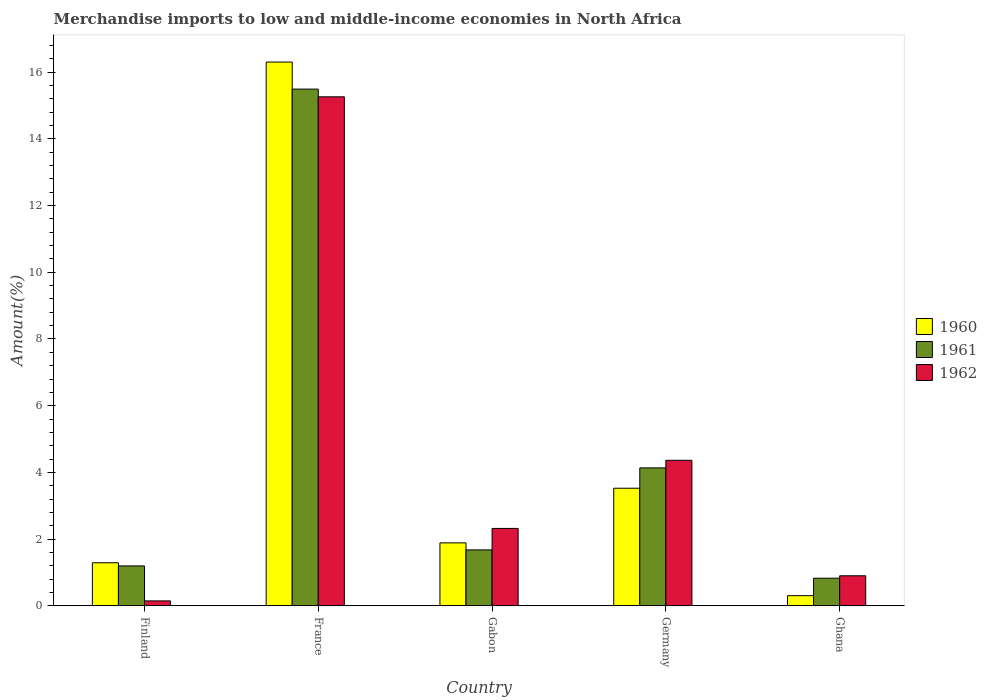How many groups of bars are there?
Give a very brief answer. 5. Are the number of bars on each tick of the X-axis equal?
Ensure brevity in your answer.  Yes. How many bars are there on the 1st tick from the left?
Ensure brevity in your answer.  3. How many bars are there on the 5th tick from the right?
Provide a short and direct response. 3. What is the label of the 3rd group of bars from the left?
Offer a terse response. Gabon. In how many cases, is the number of bars for a given country not equal to the number of legend labels?
Make the answer very short. 0. What is the percentage of amount earned from merchandise imports in 1962 in Ghana?
Your answer should be compact. 0.9. Across all countries, what is the maximum percentage of amount earned from merchandise imports in 1961?
Your answer should be very brief. 15.49. Across all countries, what is the minimum percentage of amount earned from merchandise imports in 1961?
Provide a succinct answer. 0.83. In which country was the percentage of amount earned from merchandise imports in 1962 maximum?
Ensure brevity in your answer.  France. In which country was the percentage of amount earned from merchandise imports in 1962 minimum?
Your response must be concise. Finland. What is the total percentage of amount earned from merchandise imports in 1961 in the graph?
Keep it short and to the point. 23.33. What is the difference between the percentage of amount earned from merchandise imports in 1961 in Germany and that in Ghana?
Your answer should be compact. 3.31. What is the difference between the percentage of amount earned from merchandise imports in 1962 in Ghana and the percentage of amount earned from merchandise imports in 1960 in Finland?
Offer a terse response. -0.39. What is the average percentage of amount earned from merchandise imports in 1960 per country?
Provide a short and direct response. 4.66. What is the difference between the percentage of amount earned from merchandise imports of/in 1961 and percentage of amount earned from merchandise imports of/in 1960 in France?
Provide a succinct answer. -0.81. What is the ratio of the percentage of amount earned from merchandise imports in 1961 in Gabon to that in Ghana?
Keep it short and to the point. 2.03. Is the percentage of amount earned from merchandise imports in 1962 in Finland less than that in France?
Offer a terse response. Yes. Is the difference between the percentage of amount earned from merchandise imports in 1961 in France and Gabon greater than the difference between the percentage of amount earned from merchandise imports in 1960 in France and Gabon?
Ensure brevity in your answer.  No. What is the difference between the highest and the second highest percentage of amount earned from merchandise imports in 1961?
Give a very brief answer. -2.46. What is the difference between the highest and the lowest percentage of amount earned from merchandise imports in 1960?
Keep it short and to the point. 16. Is it the case that in every country, the sum of the percentage of amount earned from merchandise imports in 1961 and percentage of amount earned from merchandise imports in 1962 is greater than the percentage of amount earned from merchandise imports in 1960?
Give a very brief answer. Yes. What is the difference between two consecutive major ticks on the Y-axis?
Keep it short and to the point. 2. Does the graph contain any zero values?
Provide a short and direct response. No. Does the graph contain grids?
Provide a succinct answer. No. How many legend labels are there?
Your response must be concise. 3. What is the title of the graph?
Your answer should be very brief. Merchandise imports to low and middle-income economies in North Africa. What is the label or title of the Y-axis?
Provide a succinct answer. Amount(%). What is the Amount(%) in 1960 in Finland?
Keep it short and to the point. 1.29. What is the Amount(%) in 1961 in Finland?
Provide a succinct answer. 1.2. What is the Amount(%) in 1962 in Finland?
Keep it short and to the point. 0.15. What is the Amount(%) in 1960 in France?
Your answer should be very brief. 16.3. What is the Amount(%) in 1961 in France?
Provide a succinct answer. 15.49. What is the Amount(%) of 1962 in France?
Offer a very short reply. 15.26. What is the Amount(%) in 1960 in Gabon?
Your response must be concise. 1.89. What is the Amount(%) in 1961 in Gabon?
Your answer should be compact. 1.68. What is the Amount(%) in 1962 in Gabon?
Your answer should be compact. 2.32. What is the Amount(%) of 1960 in Germany?
Keep it short and to the point. 3.53. What is the Amount(%) of 1961 in Germany?
Offer a terse response. 4.14. What is the Amount(%) in 1962 in Germany?
Offer a very short reply. 4.36. What is the Amount(%) of 1960 in Ghana?
Ensure brevity in your answer.  0.3. What is the Amount(%) of 1961 in Ghana?
Your answer should be very brief. 0.83. What is the Amount(%) in 1962 in Ghana?
Your answer should be very brief. 0.9. Across all countries, what is the maximum Amount(%) of 1960?
Provide a short and direct response. 16.3. Across all countries, what is the maximum Amount(%) in 1961?
Provide a short and direct response. 15.49. Across all countries, what is the maximum Amount(%) in 1962?
Offer a terse response. 15.26. Across all countries, what is the minimum Amount(%) of 1960?
Provide a succinct answer. 0.3. Across all countries, what is the minimum Amount(%) in 1961?
Give a very brief answer. 0.83. Across all countries, what is the minimum Amount(%) of 1962?
Make the answer very short. 0.15. What is the total Amount(%) in 1960 in the graph?
Offer a very short reply. 23.31. What is the total Amount(%) in 1961 in the graph?
Your response must be concise. 23.33. What is the total Amount(%) in 1962 in the graph?
Offer a terse response. 22.99. What is the difference between the Amount(%) in 1960 in Finland and that in France?
Keep it short and to the point. -15.01. What is the difference between the Amount(%) in 1961 in Finland and that in France?
Give a very brief answer. -14.3. What is the difference between the Amount(%) in 1962 in Finland and that in France?
Your response must be concise. -15.12. What is the difference between the Amount(%) in 1960 in Finland and that in Gabon?
Your answer should be very brief. -0.6. What is the difference between the Amount(%) in 1961 in Finland and that in Gabon?
Your response must be concise. -0.48. What is the difference between the Amount(%) in 1962 in Finland and that in Gabon?
Give a very brief answer. -2.17. What is the difference between the Amount(%) of 1960 in Finland and that in Germany?
Offer a very short reply. -2.23. What is the difference between the Amount(%) of 1961 in Finland and that in Germany?
Ensure brevity in your answer.  -2.94. What is the difference between the Amount(%) in 1962 in Finland and that in Germany?
Provide a short and direct response. -4.22. What is the difference between the Amount(%) in 1960 in Finland and that in Ghana?
Keep it short and to the point. 0.99. What is the difference between the Amount(%) in 1961 in Finland and that in Ghana?
Give a very brief answer. 0.37. What is the difference between the Amount(%) in 1962 in Finland and that in Ghana?
Provide a short and direct response. -0.75. What is the difference between the Amount(%) in 1960 in France and that in Gabon?
Your answer should be compact. 14.42. What is the difference between the Amount(%) in 1961 in France and that in Gabon?
Your response must be concise. 13.82. What is the difference between the Amount(%) of 1962 in France and that in Gabon?
Ensure brevity in your answer.  12.94. What is the difference between the Amount(%) of 1960 in France and that in Germany?
Ensure brevity in your answer.  12.78. What is the difference between the Amount(%) of 1961 in France and that in Germany?
Provide a short and direct response. 11.36. What is the difference between the Amount(%) in 1962 in France and that in Germany?
Offer a terse response. 10.9. What is the difference between the Amount(%) in 1960 in France and that in Ghana?
Ensure brevity in your answer.  16. What is the difference between the Amount(%) in 1961 in France and that in Ghana?
Make the answer very short. 14.67. What is the difference between the Amount(%) of 1962 in France and that in Ghana?
Give a very brief answer. 14.36. What is the difference between the Amount(%) of 1960 in Gabon and that in Germany?
Your answer should be very brief. -1.64. What is the difference between the Amount(%) of 1961 in Gabon and that in Germany?
Provide a succinct answer. -2.46. What is the difference between the Amount(%) in 1962 in Gabon and that in Germany?
Your answer should be very brief. -2.04. What is the difference between the Amount(%) of 1960 in Gabon and that in Ghana?
Your answer should be very brief. 1.58. What is the difference between the Amount(%) in 1961 in Gabon and that in Ghana?
Make the answer very short. 0.85. What is the difference between the Amount(%) in 1962 in Gabon and that in Ghana?
Your answer should be very brief. 1.42. What is the difference between the Amount(%) in 1960 in Germany and that in Ghana?
Keep it short and to the point. 3.22. What is the difference between the Amount(%) in 1961 in Germany and that in Ghana?
Your answer should be compact. 3.31. What is the difference between the Amount(%) in 1962 in Germany and that in Ghana?
Your answer should be very brief. 3.46. What is the difference between the Amount(%) in 1960 in Finland and the Amount(%) in 1961 in France?
Offer a terse response. -14.2. What is the difference between the Amount(%) of 1960 in Finland and the Amount(%) of 1962 in France?
Give a very brief answer. -13.97. What is the difference between the Amount(%) in 1961 in Finland and the Amount(%) in 1962 in France?
Your response must be concise. -14.07. What is the difference between the Amount(%) in 1960 in Finland and the Amount(%) in 1961 in Gabon?
Provide a short and direct response. -0.39. What is the difference between the Amount(%) in 1960 in Finland and the Amount(%) in 1962 in Gabon?
Keep it short and to the point. -1.03. What is the difference between the Amount(%) of 1961 in Finland and the Amount(%) of 1962 in Gabon?
Provide a short and direct response. -1.12. What is the difference between the Amount(%) of 1960 in Finland and the Amount(%) of 1961 in Germany?
Ensure brevity in your answer.  -2.84. What is the difference between the Amount(%) in 1960 in Finland and the Amount(%) in 1962 in Germany?
Provide a succinct answer. -3.07. What is the difference between the Amount(%) of 1961 in Finland and the Amount(%) of 1962 in Germany?
Make the answer very short. -3.17. What is the difference between the Amount(%) in 1960 in Finland and the Amount(%) in 1961 in Ghana?
Provide a succinct answer. 0.46. What is the difference between the Amount(%) in 1960 in Finland and the Amount(%) in 1962 in Ghana?
Keep it short and to the point. 0.39. What is the difference between the Amount(%) of 1961 in Finland and the Amount(%) of 1962 in Ghana?
Ensure brevity in your answer.  0.3. What is the difference between the Amount(%) of 1960 in France and the Amount(%) of 1961 in Gabon?
Provide a succinct answer. 14.63. What is the difference between the Amount(%) of 1960 in France and the Amount(%) of 1962 in Gabon?
Provide a succinct answer. 13.98. What is the difference between the Amount(%) of 1961 in France and the Amount(%) of 1962 in Gabon?
Keep it short and to the point. 13.17. What is the difference between the Amount(%) of 1960 in France and the Amount(%) of 1961 in Germany?
Your answer should be very brief. 12.17. What is the difference between the Amount(%) in 1960 in France and the Amount(%) in 1962 in Germany?
Offer a very short reply. 11.94. What is the difference between the Amount(%) of 1961 in France and the Amount(%) of 1962 in Germany?
Your response must be concise. 11.13. What is the difference between the Amount(%) of 1960 in France and the Amount(%) of 1961 in Ghana?
Your response must be concise. 15.48. What is the difference between the Amount(%) in 1960 in France and the Amount(%) in 1962 in Ghana?
Provide a short and direct response. 15.4. What is the difference between the Amount(%) of 1961 in France and the Amount(%) of 1962 in Ghana?
Ensure brevity in your answer.  14.59. What is the difference between the Amount(%) of 1960 in Gabon and the Amount(%) of 1961 in Germany?
Make the answer very short. -2.25. What is the difference between the Amount(%) in 1960 in Gabon and the Amount(%) in 1962 in Germany?
Ensure brevity in your answer.  -2.48. What is the difference between the Amount(%) in 1961 in Gabon and the Amount(%) in 1962 in Germany?
Offer a very short reply. -2.69. What is the difference between the Amount(%) in 1960 in Gabon and the Amount(%) in 1961 in Ghana?
Make the answer very short. 1.06. What is the difference between the Amount(%) of 1960 in Gabon and the Amount(%) of 1962 in Ghana?
Offer a terse response. 0.99. What is the difference between the Amount(%) in 1961 in Gabon and the Amount(%) in 1962 in Ghana?
Offer a terse response. 0.78. What is the difference between the Amount(%) of 1960 in Germany and the Amount(%) of 1961 in Ghana?
Offer a terse response. 2.7. What is the difference between the Amount(%) of 1960 in Germany and the Amount(%) of 1962 in Ghana?
Provide a short and direct response. 2.63. What is the difference between the Amount(%) in 1961 in Germany and the Amount(%) in 1962 in Ghana?
Give a very brief answer. 3.23. What is the average Amount(%) of 1960 per country?
Your response must be concise. 4.66. What is the average Amount(%) in 1961 per country?
Offer a very short reply. 4.67. What is the average Amount(%) in 1962 per country?
Keep it short and to the point. 4.6. What is the difference between the Amount(%) of 1960 and Amount(%) of 1961 in Finland?
Ensure brevity in your answer.  0.09. What is the difference between the Amount(%) in 1960 and Amount(%) in 1962 in Finland?
Offer a terse response. 1.14. What is the difference between the Amount(%) in 1961 and Amount(%) in 1962 in Finland?
Offer a very short reply. 1.05. What is the difference between the Amount(%) in 1960 and Amount(%) in 1961 in France?
Your answer should be very brief. 0.81. What is the difference between the Amount(%) in 1960 and Amount(%) in 1962 in France?
Offer a terse response. 1.04. What is the difference between the Amount(%) in 1961 and Amount(%) in 1962 in France?
Offer a terse response. 0.23. What is the difference between the Amount(%) in 1960 and Amount(%) in 1961 in Gabon?
Give a very brief answer. 0.21. What is the difference between the Amount(%) of 1960 and Amount(%) of 1962 in Gabon?
Your answer should be very brief. -0.43. What is the difference between the Amount(%) in 1961 and Amount(%) in 1962 in Gabon?
Make the answer very short. -0.64. What is the difference between the Amount(%) in 1960 and Amount(%) in 1961 in Germany?
Make the answer very short. -0.61. What is the difference between the Amount(%) in 1960 and Amount(%) in 1962 in Germany?
Keep it short and to the point. -0.84. What is the difference between the Amount(%) of 1961 and Amount(%) of 1962 in Germany?
Make the answer very short. -0.23. What is the difference between the Amount(%) of 1960 and Amount(%) of 1961 in Ghana?
Provide a succinct answer. -0.52. What is the difference between the Amount(%) of 1960 and Amount(%) of 1962 in Ghana?
Your response must be concise. -0.6. What is the difference between the Amount(%) in 1961 and Amount(%) in 1962 in Ghana?
Make the answer very short. -0.07. What is the ratio of the Amount(%) in 1960 in Finland to that in France?
Offer a very short reply. 0.08. What is the ratio of the Amount(%) of 1961 in Finland to that in France?
Give a very brief answer. 0.08. What is the ratio of the Amount(%) of 1962 in Finland to that in France?
Your response must be concise. 0.01. What is the ratio of the Amount(%) of 1960 in Finland to that in Gabon?
Provide a succinct answer. 0.68. What is the ratio of the Amount(%) in 1961 in Finland to that in Gabon?
Offer a very short reply. 0.71. What is the ratio of the Amount(%) of 1962 in Finland to that in Gabon?
Your answer should be compact. 0.06. What is the ratio of the Amount(%) of 1960 in Finland to that in Germany?
Make the answer very short. 0.37. What is the ratio of the Amount(%) in 1961 in Finland to that in Germany?
Provide a succinct answer. 0.29. What is the ratio of the Amount(%) in 1962 in Finland to that in Germany?
Your answer should be compact. 0.03. What is the ratio of the Amount(%) in 1960 in Finland to that in Ghana?
Provide a succinct answer. 4.25. What is the ratio of the Amount(%) of 1961 in Finland to that in Ghana?
Your answer should be compact. 1.45. What is the ratio of the Amount(%) of 1962 in Finland to that in Ghana?
Offer a terse response. 0.16. What is the ratio of the Amount(%) of 1960 in France to that in Gabon?
Make the answer very short. 8.64. What is the ratio of the Amount(%) of 1961 in France to that in Gabon?
Your response must be concise. 9.24. What is the ratio of the Amount(%) in 1962 in France to that in Gabon?
Provide a succinct answer. 6.58. What is the ratio of the Amount(%) in 1960 in France to that in Germany?
Ensure brevity in your answer.  4.62. What is the ratio of the Amount(%) of 1961 in France to that in Germany?
Your answer should be very brief. 3.75. What is the ratio of the Amount(%) in 1962 in France to that in Germany?
Your answer should be very brief. 3.5. What is the ratio of the Amount(%) in 1960 in France to that in Ghana?
Ensure brevity in your answer.  53.67. What is the ratio of the Amount(%) of 1961 in France to that in Ghana?
Offer a terse response. 18.72. What is the ratio of the Amount(%) of 1962 in France to that in Ghana?
Your response must be concise. 16.95. What is the ratio of the Amount(%) of 1960 in Gabon to that in Germany?
Ensure brevity in your answer.  0.54. What is the ratio of the Amount(%) in 1961 in Gabon to that in Germany?
Give a very brief answer. 0.41. What is the ratio of the Amount(%) in 1962 in Gabon to that in Germany?
Provide a short and direct response. 0.53. What is the ratio of the Amount(%) in 1960 in Gabon to that in Ghana?
Make the answer very short. 6.21. What is the ratio of the Amount(%) in 1961 in Gabon to that in Ghana?
Your answer should be very brief. 2.03. What is the ratio of the Amount(%) of 1962 in Gabon to that in Ghana?
Ensure brevity in your answer.  2.58. What is the ratio of the Amount(%) of 1960 in Germany to that in Ghana?
Provide a succinct answer. 11.61. What is the ratio of the Amount(%) in 1961 in Germany to that in Ghana?
Provide a short and direct response. 5. What is the ratio of the Amount(%) of 1962 in Germany to that in Ghana?
Your response must be concise. 4.85. What is the difference between the highest and the second highest Amount(%) of 1960?
Offer a very short reply. 12.78. What is the difference between the highest and the second highest Amount(%) in 1961?
Provide a short and direct response. 11.36. What is the difference between the highest and the second highest Amount(%) of 1962?
Give a very brief answer. 10.9. What is the difference between the highest and the lowest Amount(%) of 1960?
Your answer should be very brief. 16. What is the difference between the highest and the lowest Amount(%) of 1961?
Offer a very short reply. 14.67. What is the difference between the highest and the lowest Amount(%) in 1962?
Your answer should be very brief. 15.12. 